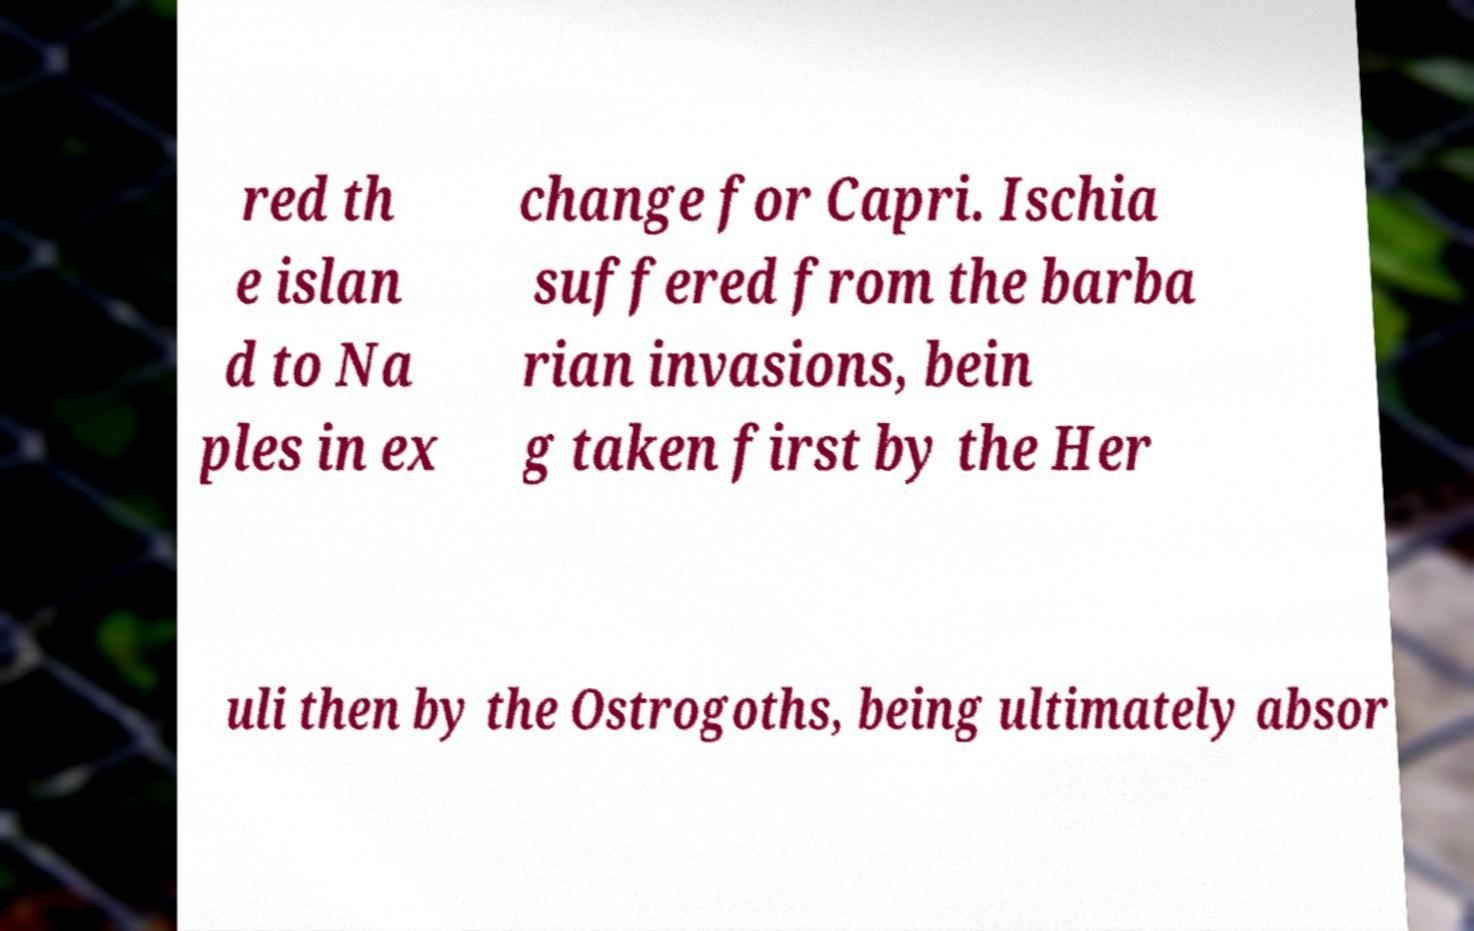What messages or text are displayed in this image? I need them in a readable, typed format. red th e islan d to Na ples in ex change for Capri. Ischia suffered from the barba rian invasions, bein g taken first by the Her uli then by the Ostrogoths, being ultimately absor 